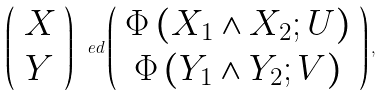Convert formula to latex. <formula><loc_0><loc_0><loc_500><loc_500>\left ( \begin{array} { c } X \\ Y \end{array} \right ) \ e d \left ( \begin{array} { c } \Phi \left ( X _ { 1 } \wedge X _ { 2 } ; U \right ) \\ \Phi \left ( Y _ { 1 } \wedge Y _ { 2 } ; V \right ) \end{array} \right ) ,</formula> 